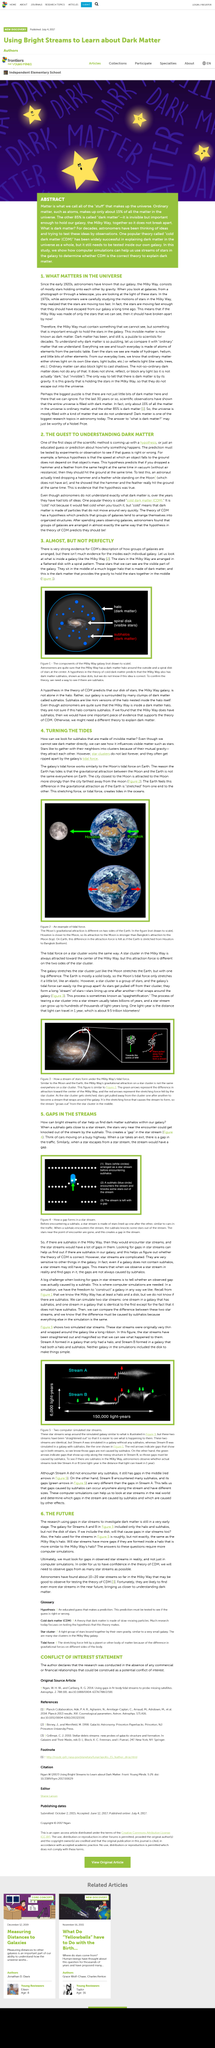Identify some key points in this picture. The speed at which the stars in the Milky Way are moving is not significant in relation to what is important in the universe. There is not much evidence available to support the idea of how the insides of individual galaxies are arranged. Ordinary matter, which makes up 15% of all matter in the universe, is composed of its percentage component. The escape of a star from the stream creates an alternative way for a gap to be formed. The article discusses gaps in star streams. 